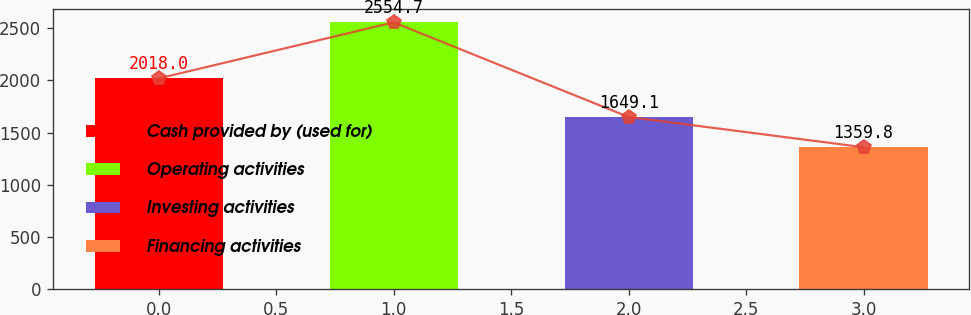<chart> <loc_0><loc_0><loc_500><loc_500><bar_chart><fcel>Cash provided by (used for)<fcel>Operating activities<fcel>Investing activities<fcel>Financing activities<nl><fcel>2018<fcel>2554.7<fcel>1649.1<fcel>1359.8<nl></chart> 